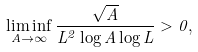Convert formula to latex. <formula><loc_0><loc_0><loc_500><loc_500>\liminf _ { A \to \infty } \frac { \sqrt { A } } { L ^ { 2 } \log A \log L } > 0 ,</formula> 